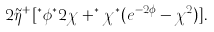<formula> <loc_0><loc_0><loc_500><loc_500>2 \tilde { \eta } ^ { + } [ ^ { * } \phi ^ { * } 2 \chi + ^ { * } \chi ^ { * } ( e ^ { - 2 \phi } - \chi ^ { 2 } ) ] .</formula> 